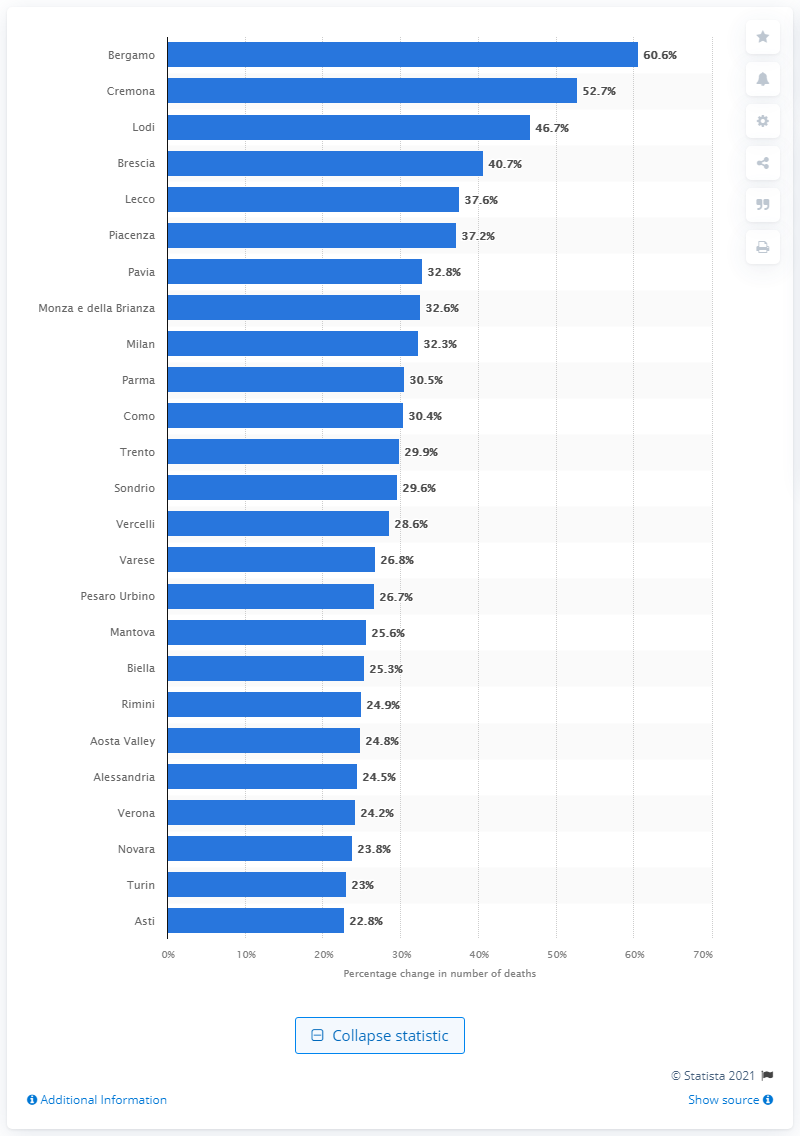Give some essential details in this illustration. Lombardy is a province located in the region of Lombardy, and Bergamo is located within the province of Lombardy. 